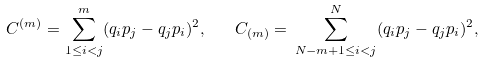Convert formula to latex. <formula><loc_0><loc_0><loc_500><loc_500>C ^ { ( m ) } = \sum _ { 1 \leq i < j } ^ { m } ( { q _ { i } } { p _ { j } } - { q _ { j } } { p _ { i } } ) ^ { 2 } , \quad C _ { ( m ) } = \, \sum _ { N - m + 1 \leq i < j } ^ { N } ( { q _ { i } } { p _ { j } } - { q _ { j } } { p _ { i } } ) ^ { 2 } ,</formula> 